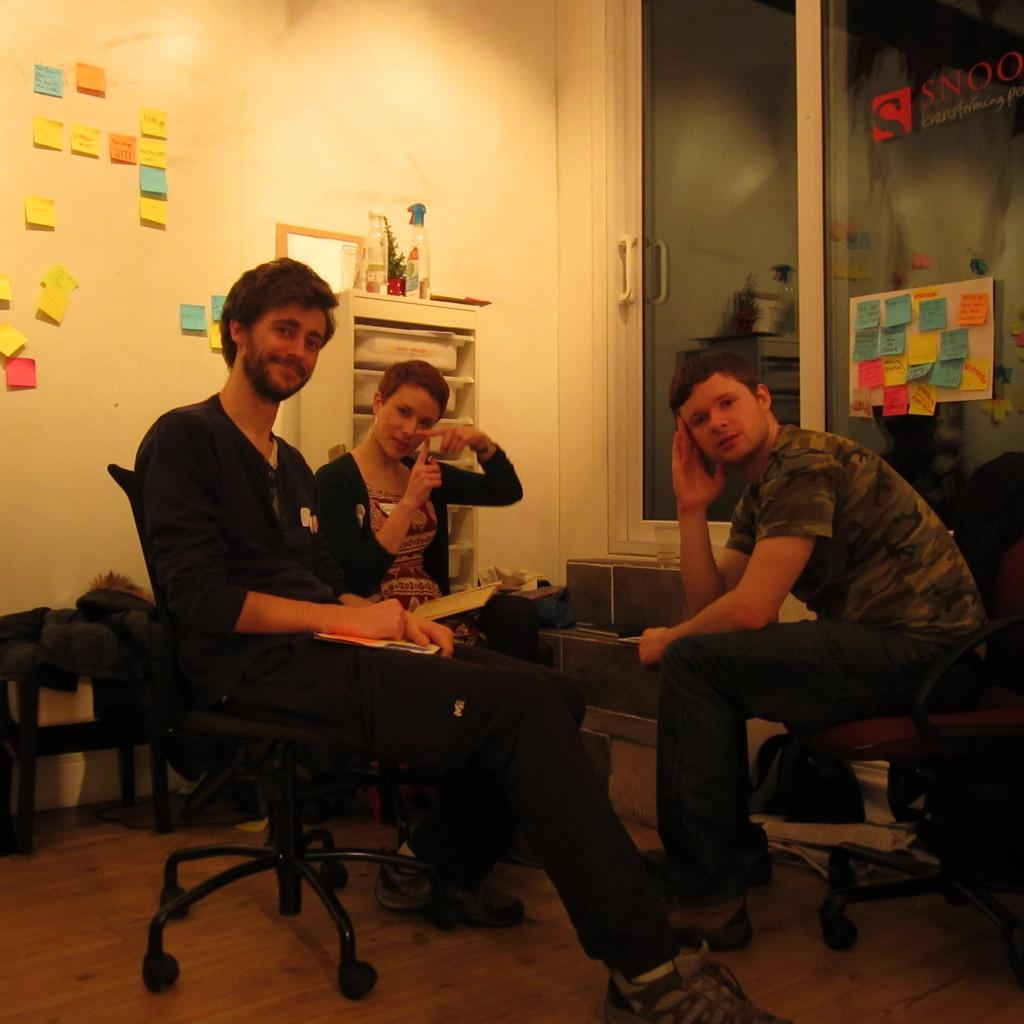How many people are sitting on the chair in the image? There are three people sitting on a chair in the image. What can be seen in the background of the image? There is a bookshelf in the image. What object is visible on the table to the left in the image? There is a bottle in the image. What is attached to the wall in the image? There are papers on the wall in the image. What type of wood can be seen in the image? There is no wood visible in the image. The image does not show any wooden objects or structures. 